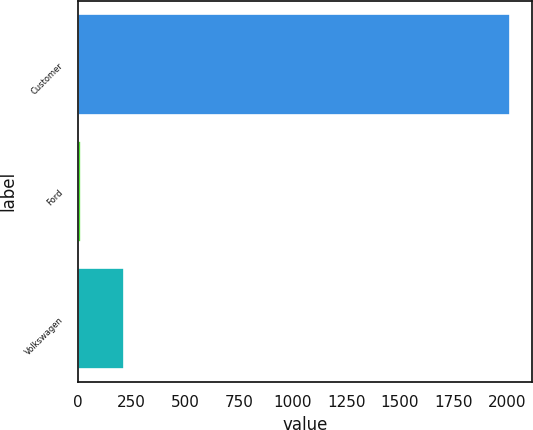Convert chart to OTSL. <chart><loc_0><loc_0><loc_500><loc_500><bar_chart><fcel>Customer<fcel>Ford<fcel>Volkswagen<nl><fcel>2015<fcel>15<fcel>215<nl></chart> 